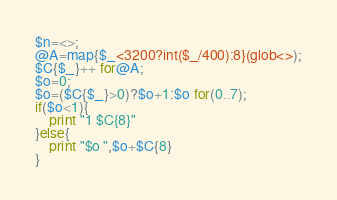<code> <loc_0><loc_0><loc_500><loc_500><_Perl_>$n=<>;
@A=map{$_<3200?int($_/400):8}(glob<>);
$C{$_}++ for@A;
$o=0;
$o=($C{$_}>0)?$o+1:$o for(0..7);
if($o<1){
    print "1 $C{8}"
}else{
    print "$o ",$o+$C{8}
}</code> 